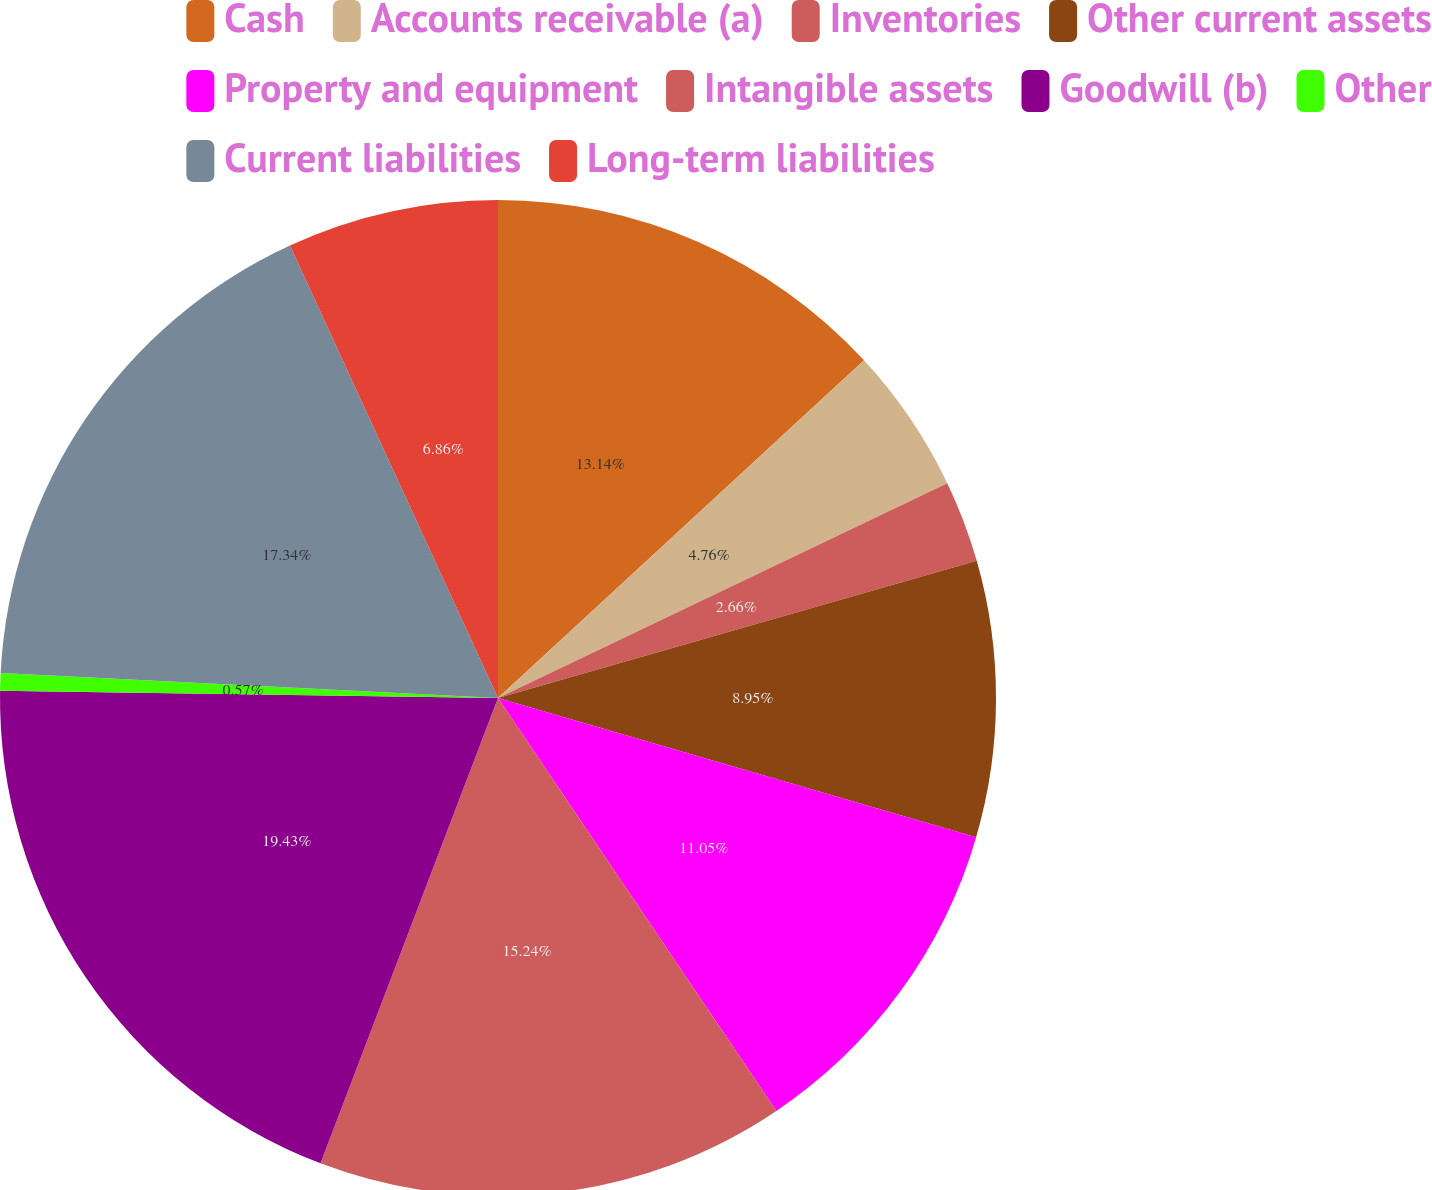Convert chart. <chart><loc_0><loc_0><loc_500><loc_500><pie_chart><fcel>Cash<fcel>Accounts receivable (a)<fcel>Inventories<fcel>Other current assets<fcel>Property and equipment<fcel>Intangible assets<fcel>Goodwill (b)<fcel>Other<fcel>Current liabilities<fcel>Long-term liabilities<nl><fcel>13.14%<fcel>4.76%<fcel>2.66%<fcel>8.95%<fcel>11.05%<fcel>15.24%<fcel>19.43%<fcel>0.57%<fcel>17.34%<fcel>6.86%<nl></chart> 